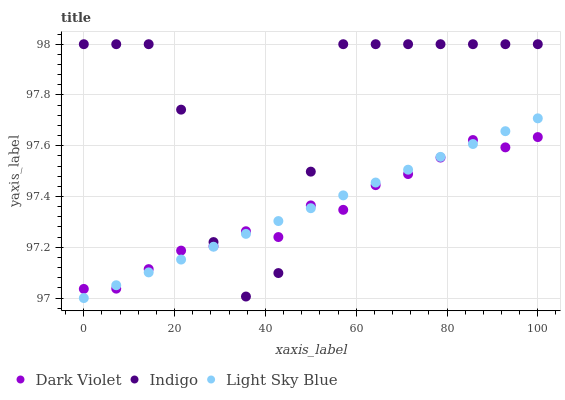Does Dark Violet have the minimum area under the curve?
Answer yes or no. Yes. Does Indigo have the maximum area under the curve?
Answer yes or no. Yes. Does Indigo have the minimum area under the curve?
Answer yes or no. No. Does Dark Violet have the maximum area under the curve?
Answer yes or no. No. Is Light Sky Blue the smoothest?
Answer yes or no. Yes. Is Indigo the roughest?
Answer yes or no. Yes. Is Dark Violet the smoothest?
Answer yes or no. No. Is Dark Violet the roughest?
Answer yes or no. No. Does Light Sky Blue have the lowest value?
Answer yes or no. Yes. Does Indigo have the lowest value?
Answer yes or no. No. Does Indigo have the highest value?
Answer yes or no. Yes. Does Dark Violet have the highest value?
Answer yes or no. No. Does Dark Violet intersect Light Sky Blue?
Answer yes or no. Yes. Is Dark Violet less than Light Sky Blue?
Answer yes or no. No. Is Dark Violet greater than Light Sky Blue?
Answer yes or no. No. 